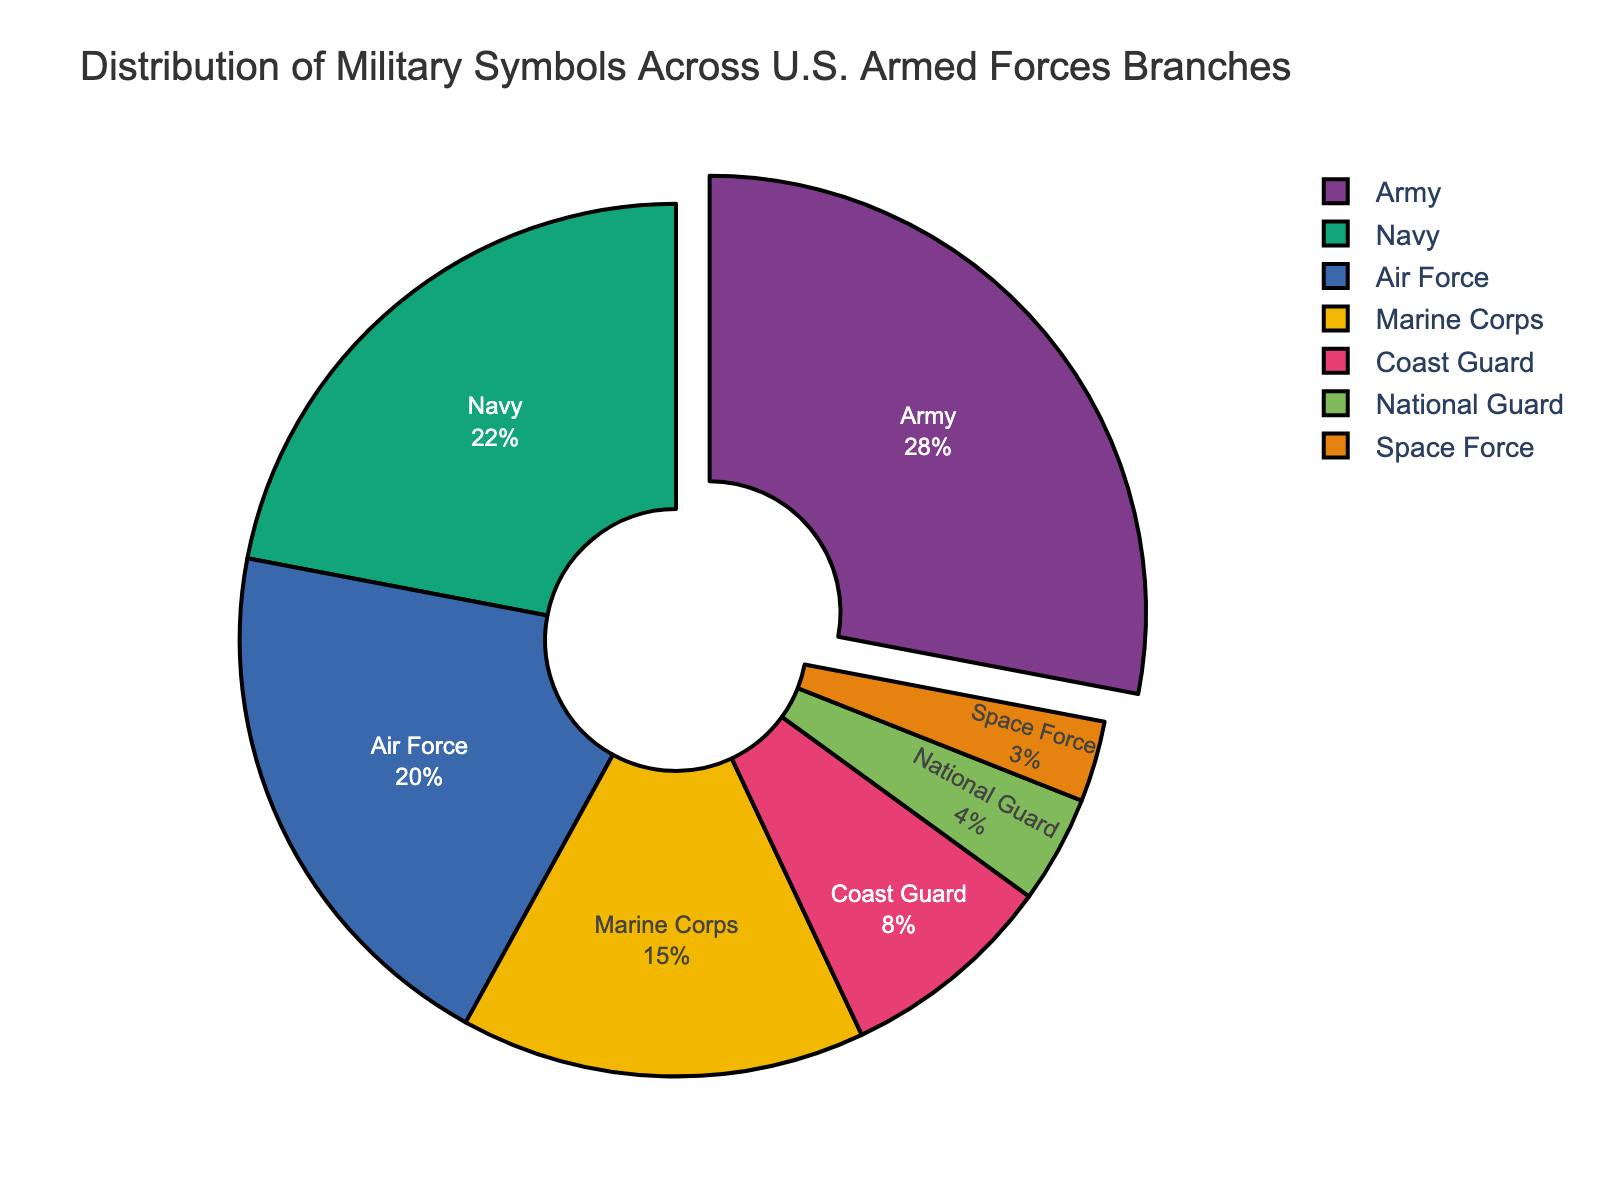What is the percentage of symbols representing the Air Force? The Air Force section is labeled with its percentage on the pie chart. Look for this label.
Answer: 20% Which branch has the smallest representation in terms of military symbols? Identify the slice with the smallest percentage label.
Answer: Space Force What is the difference in percentage between the Army and Marine Corps symbols? Find the percentage for the Army and the Marine Corps, then subtract the percentage of the Marine Corps from the Army. Army is 28%, and Marine Corps is 15%, so the difference is 28 - 15.
Answer: 13% Sum the percentages of the Navy and Air Force military symbols. Find the percentage for the Navy and Air Force, then add them together. Navy is 22% and Air Force is 20%, so the sum is 22 + 20.
Answer: 42% What is the total percentage of symbols represented by the Coast Guard and National Guard combined? Find the percentage for the Coast Guard and the National Guard, then add them together. Coast Guard is 8% and National Guard is 4%, so the total is 8 + 4.
Answer: 12% Which branch has a percentage closest to 20%? Compare the labels representing the percentages for each branch and find the one closest to 20%. The Air Force is labeled as 20%.
Answer: Air Force How many branches have a representation percentage below 10%? Look for the slices with a percentage label below 10% and count them.
Answer: 3 Which branch's symbol representation is highlighted or pulled out from the pie chart? Identify the slice that is pulled out from the center of the pie.
Answer: Army How much higher is the Army's percentage compared to the Navy's? Find the percentage difference between the Army and Navy by subtracting Navy's percentage from Army's. Army is 28%, and Navy is 22%, so the difference is 28 - 22.
Answer: 6% 